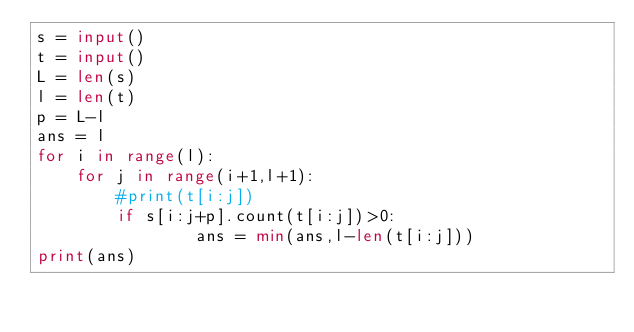Convert code to text. <code><loc_0><loc_0><loc_500><loc_500><_Python_>s = input()
t = input()
L = len(s)
l = len(t)
p = L-l
ans = l
for i in range(l):
    for j in range(i+1,l+1):
        #print(t[i:j])
        if s[i:j+p].count(t[i:j])>0:
                ans = min(ans,l-len(t[i:j]))
print(ans)</code> 